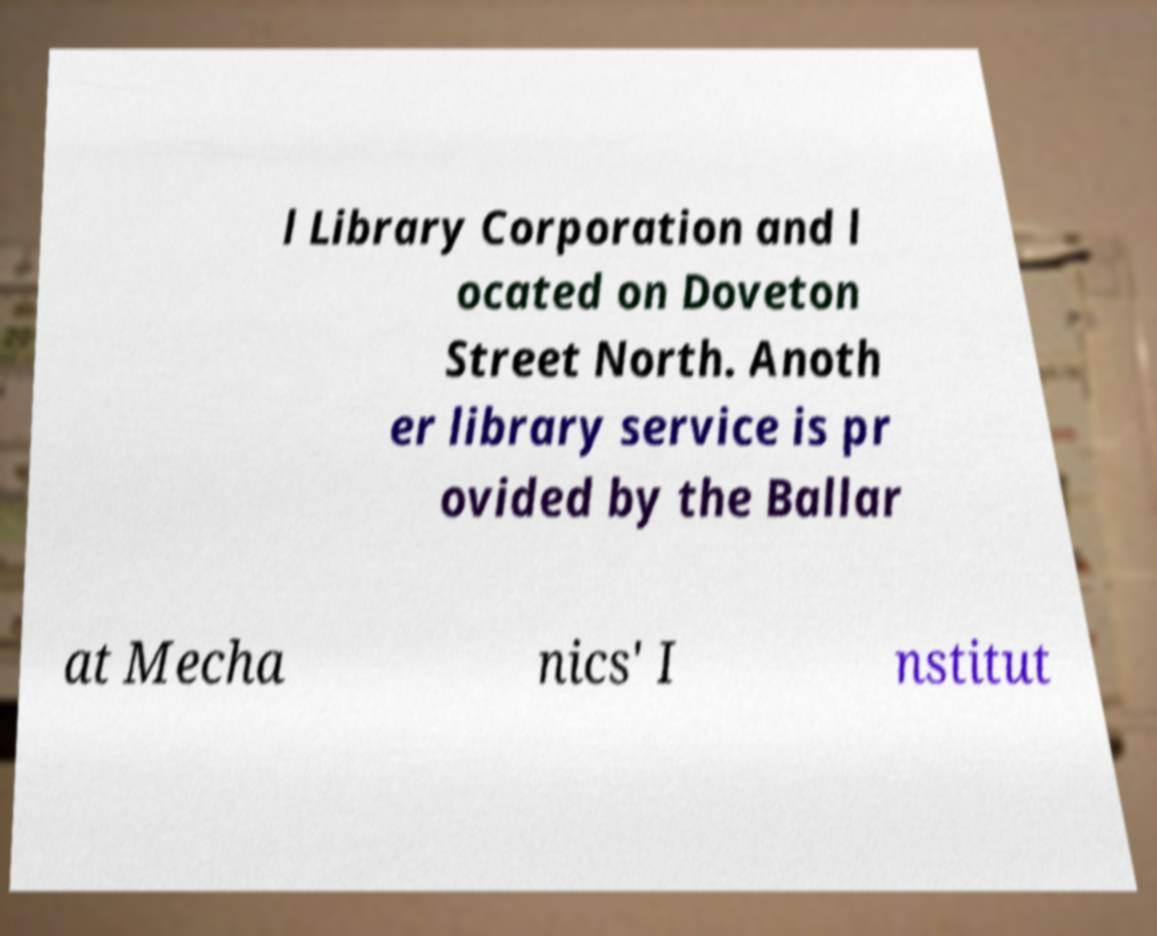Can you read and provide the text displayed in the image?This photo seems to have some interesting text. Can you extract and type it out for me? l Library Corporation and l ocated on Doveton Street North. Anoth er library service is pr ovided by the Ballar at Mecha nics' I nstitut 